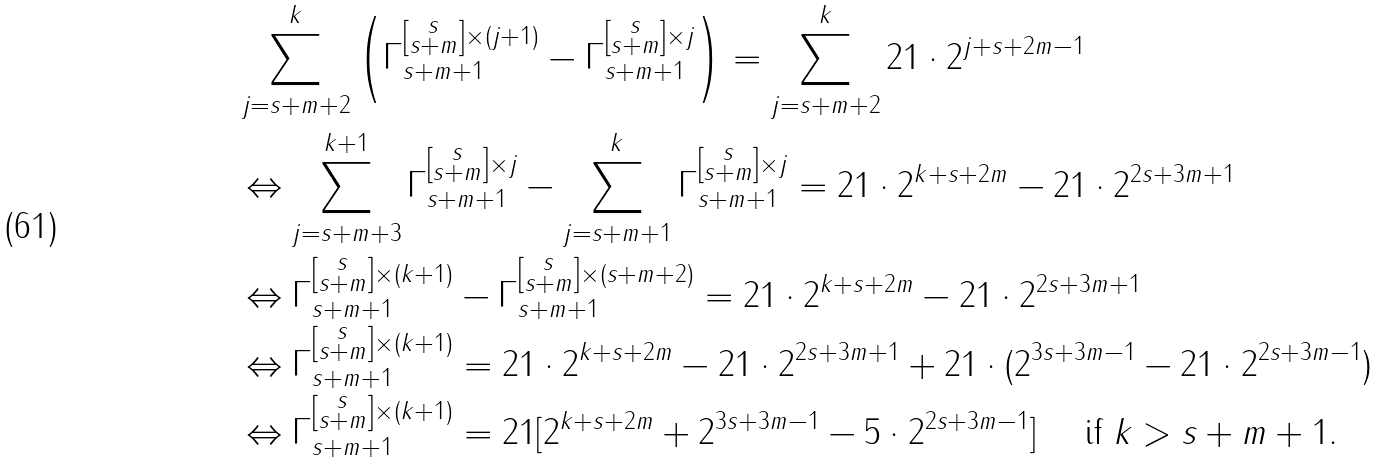Convert formula to latex. <formula><loc_0><loc_0><loc_500><loc_500>& \sum _ { j = s + m + 2 } ^ { k } \left ( \Gamma _ { s + m + 1 } ^ { \left [ \substack { s \\ s + m } \right ] \times ( j + 1 ) } - \Gamma _ { s + m + 1 } ^ { \left [ \substack { s \\ s + m } \right ] \times j } \right ) = \sum _ { j = s + m + 2 } ^ { k } 2 1 \cdot 2 ^ { j + s + 2 m - 1 } \\ & \Leftrightarrow \sum _ { j = s + m + 3 } ^ { k + 1 } \Gamma _ { s + m + 1 } ^ { \left [ \substack { s \\ s + m } \right ] \times j } - \sum _ { j = s + m + 1 } ^ { k } \Gamma _ { s + m + 1 } ^ { \left [ \substack { s \\ s + m } \right ] \times j } = 2 1 \cdot 2 ^ { k + s + 2 m } - 2 1 \cdot 2 ^ { 2 s + 3 m + 1 } \\ & \Leftrightarrow \Gamma _ { s + m + 1 } ^ { \left [ \substack { s \\ s + m } \right ] \times ( k + 1 ) } - \Gamma _ { s + m + 1 } ^ { \left [ \substack { s \\ s + m } \right ] \times ( s + m + 2 ) } = 2 1 \cdot 2 ^ { k + s + 2 m } - 2 1 \cdot 2 ^ { 2 s + 3 m + 1 } \\ & \Leftrightarrow \Gamma _ { s + m + 1 } ^ { \left [ \substack { s \\ s + m } \right ] \times ( k + 1 ) } = 2 1 \cdot 2 ^ { k + s + 2 m } - 2 1 \cdot 2 ^ { 2 s + 3 m + 1 } + 2 1 \cdot ( 2 ^ { 3 s + 3 m - 1 } - 2 1 \cdot 2 ^ { 2 s + 3 m - 1 } ) \\ & \Leftrightarrow \Gamma _ { s + m + 1 } ^ { \left [ \substack { s \\ s + m } \right ] \times ( k + 1 ) } = 2 1 [ 2 ^ { k + s + 2 m } + 2 ^ { 3 s + 3 m - 1 } - 5 \cdot 2 ^ { 2 s + 3 m - 1 } ] \quad \text { if $ k > s + m+1 $} .</formula> 